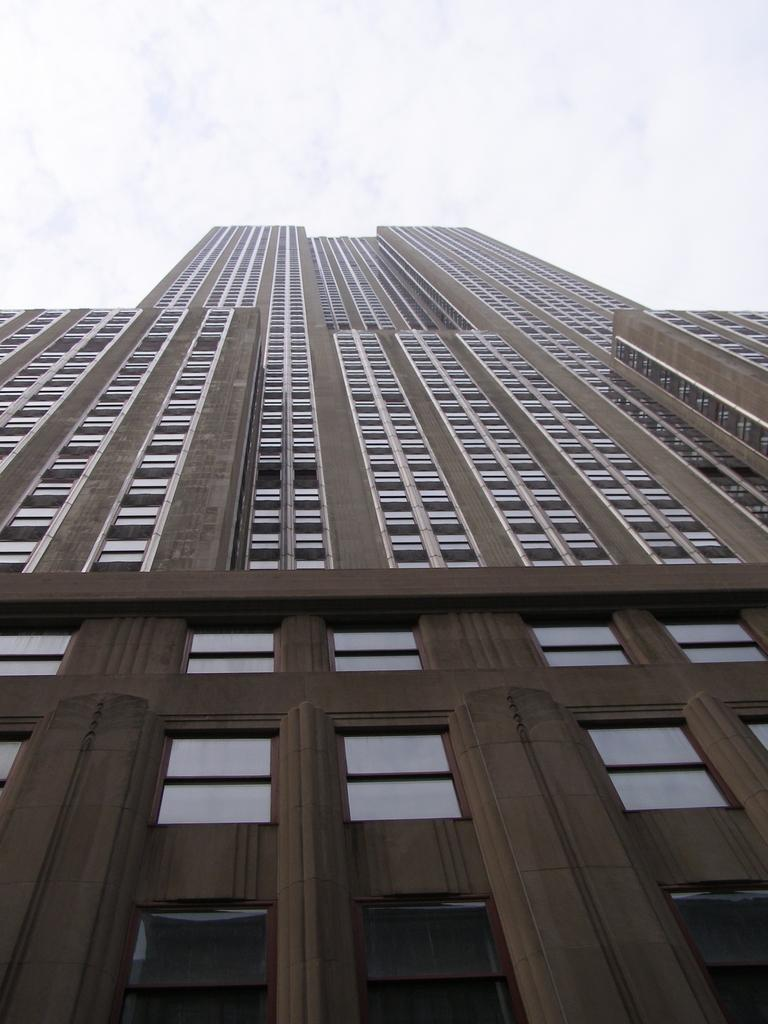What type of structure is present in the image? There is a building in the image. What feature can be observed on the building? The building has glass windows. What is visible at the top of the image? The sky is visible at the top of the image. What substance is being used to tell a joke in the image? There is no substance or joke present in the image; it features a building with glass windows and a visible sky. 